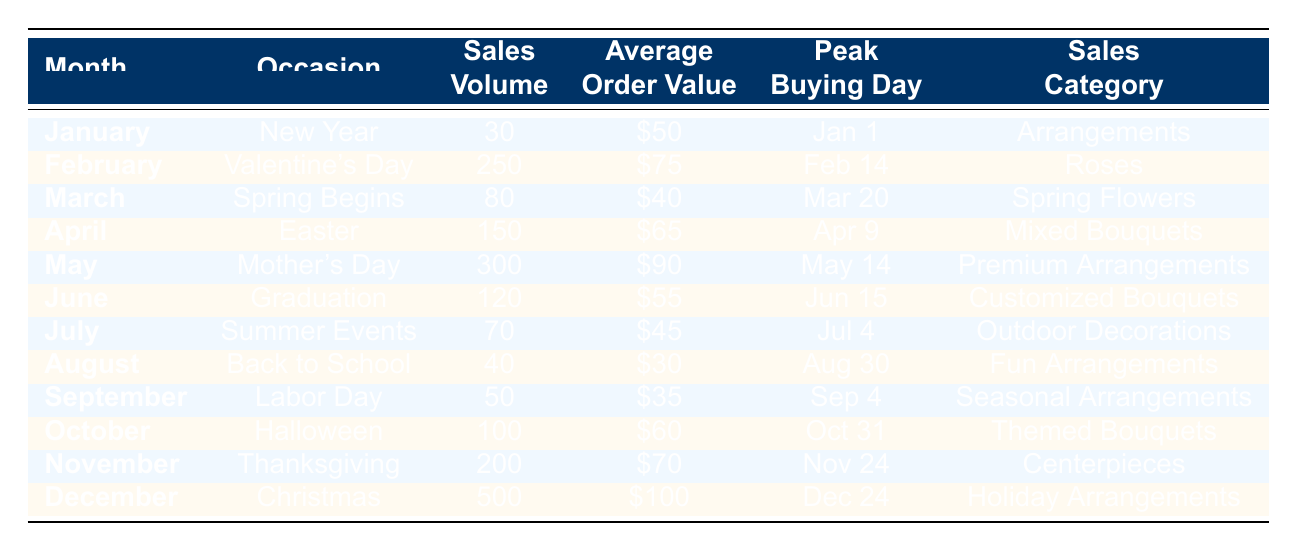What is the sales volume for December? The table lists December with a sales volume of 500.
Answer: 500 Which month has the highest average order value? December has the highest average order value of 100 according to the table.
Answer: December How many occasions have sales volumes greater than 200? Reviewing the sales volumes, only Mother's Day and Christmas have volumes exceeding 200, so there are two such occasions.
Answer: 2 What is the total sales volume for the first half of the year? The total sales volume for January (30), February (250), March (80), April (150), May (300), and June (120) is calculated as 30 + 250 + 80 + 150 + 300 + 120 = 930.
Answer: 930 Is the peak buying day for Valentine's Day in the same month as Mother's Day? Valentine's Day occurs on February 14, while Mother's Day happens on May 14, which means they occur in different months.
Answer: No What is the difference in average order value between the highest and lowest sales categories? The highest average order value is in December at 100, and the lowest is in August at 30. The difference is 100 - 30 = 70.
Answer: 70 Which category sold the most in sales volume during the year? December's Holiday Arrangements sold 500 units, which is the highest sales volume compared to all other months.
Answer: Holiday Arrangements How many months have sales volumes less than 100? By analyzing the sales volumes, January (30), March (80), July (70), and August (40) are the months with volumes below 100. This totals four months.
Answer: 4 On which day were the peak sales volumes for Easter and Thanksgiving? The peak buying day for Easter is April 9, and for Thanksgiving, it is November 24, according to the table.
Answer: April 9 and November 24 